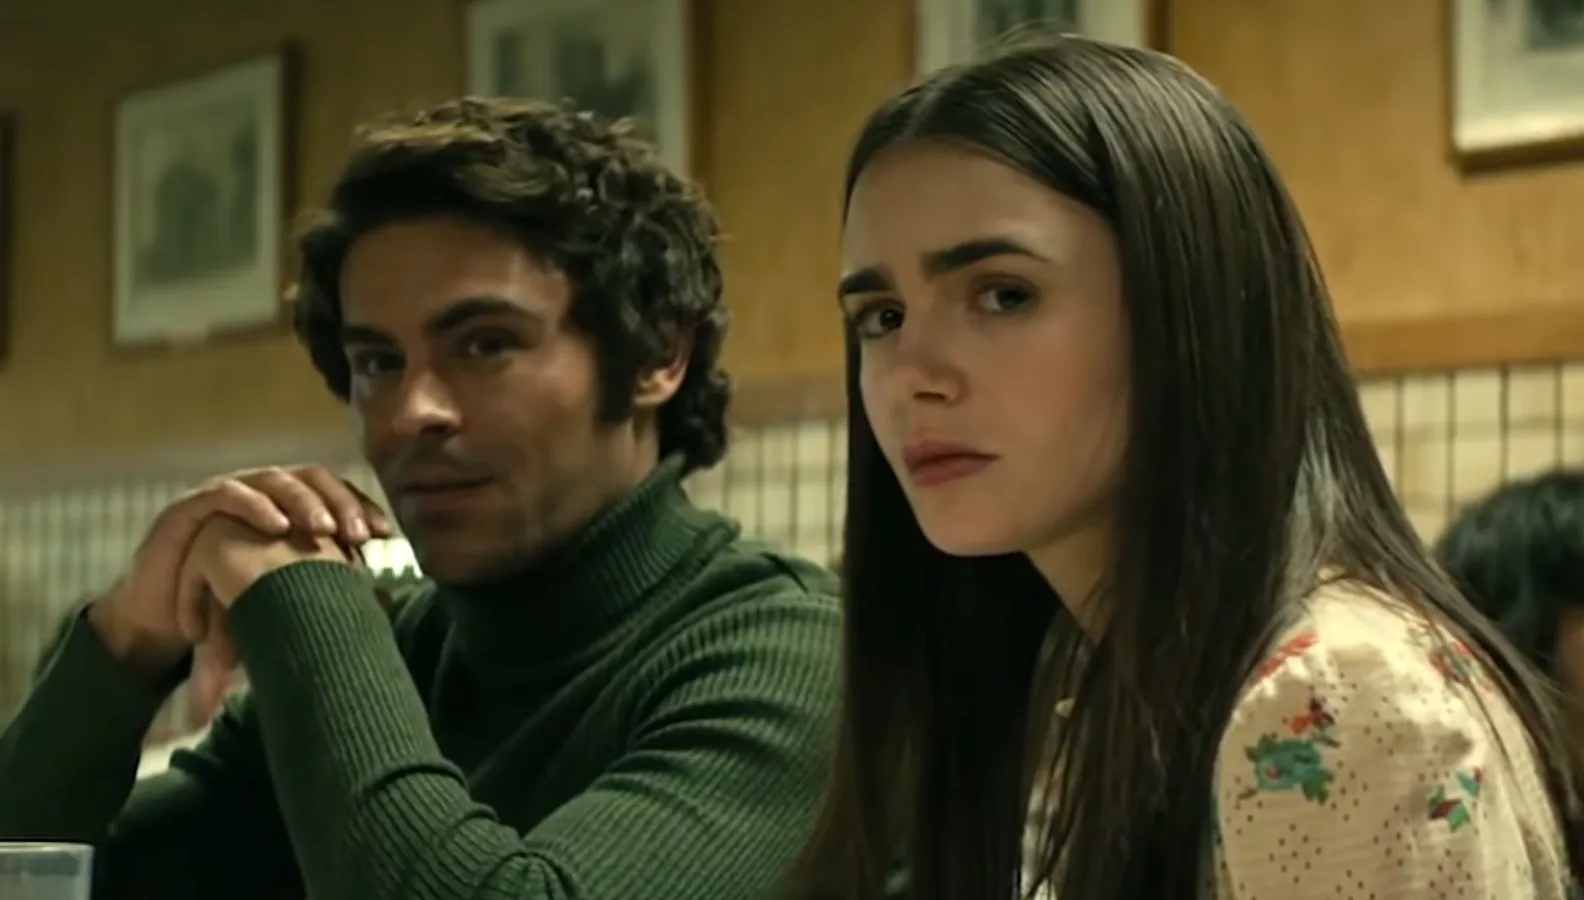What might be happening in the rest of the diner during this scene? While the characters are engrossed in their intense conversation, the rest of the diner buzzes with life. A waitress wearing a retro uniform weaves between tables, efficiently balancing multiple orders. A family of four by the window enjoys a hearty meal, the parents smiling as their children laugh and play. At the counter, a solitary figure sips coffee while reading a newspaper, occasionally glancing up at the commotion around him. The distant sound of a jukebox playing a classic tune adds to the nostalgic feel. Despite the characters' serious demeanor, the diner retains its lively, everyday pulse, carrying on with a rhythm all its own. 